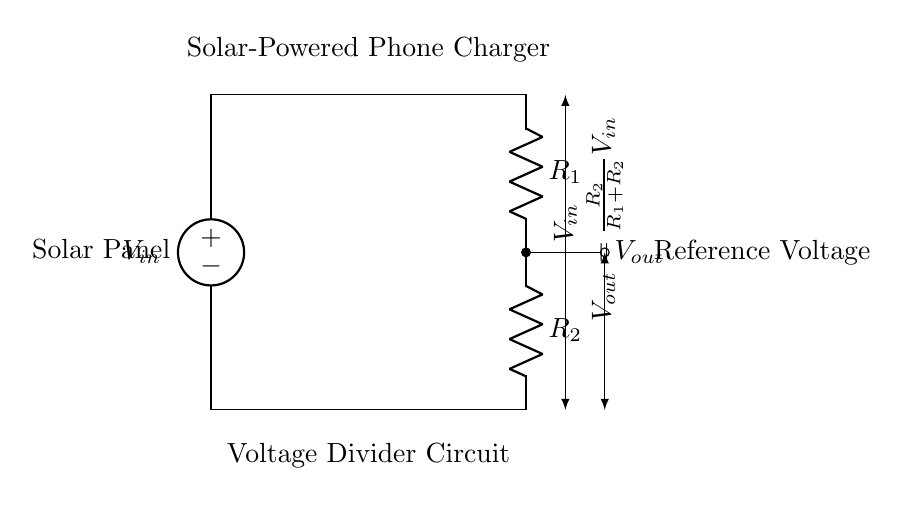What is the input voltage source labeled in the circuit? The input voltage source is labeled as “Solar Panel” which implies it is providing voltage to the circuit.
Answer: Solar Panel What are the values of the resistors in the voltage divider? The circuit diagram identifies two resistors as R1 and R2, but does not provide numerical values; they are identified only by their labels.
Answer: R1 and R2 What connects the output to the reference voltage? The output labeled as Vout is connected to the midpoint between resistors R1 and R2, which is indicative of where the reference voltage is created.
Answer: Resistor divider What is the formula for the output voltage in this circuit? The formula is stated in the circuit as Vout equals R2 divided by the sum of R1 and R2 times Vin, which represents how output voltage is derived in relation to input voltage and resistor values.
Answer: Vout = R2/(R1+R2)Vin Why is a voltage divider used in a solar-powered phone charger? The voltage divider is used to create a reference voltage that can be used for safely charging a phone, ensuring that the device does not receive more voltage than it can handle from the solar panel.
Answer: To create reference voltage 